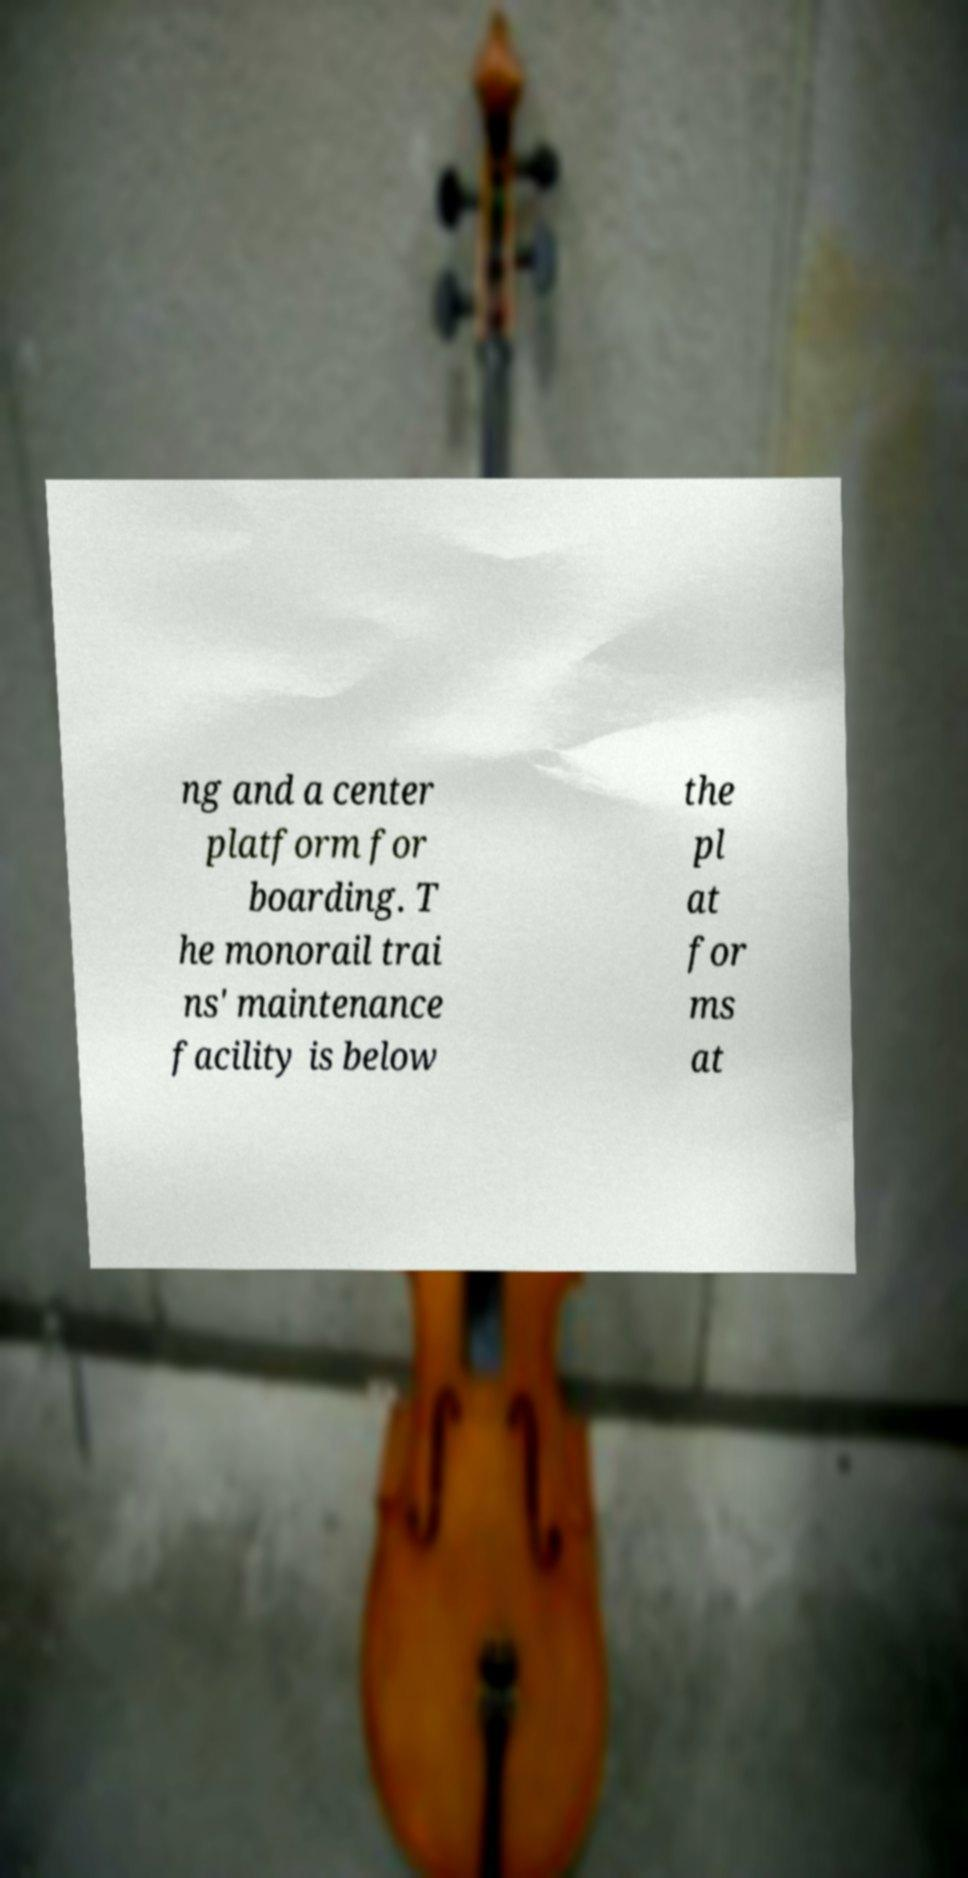What messages or text are displayed in this image? I need them in a readable, typed format. ng and a center platform for boarding. T he monorail trai ns' maintenance facility is below the pl at for ms at 